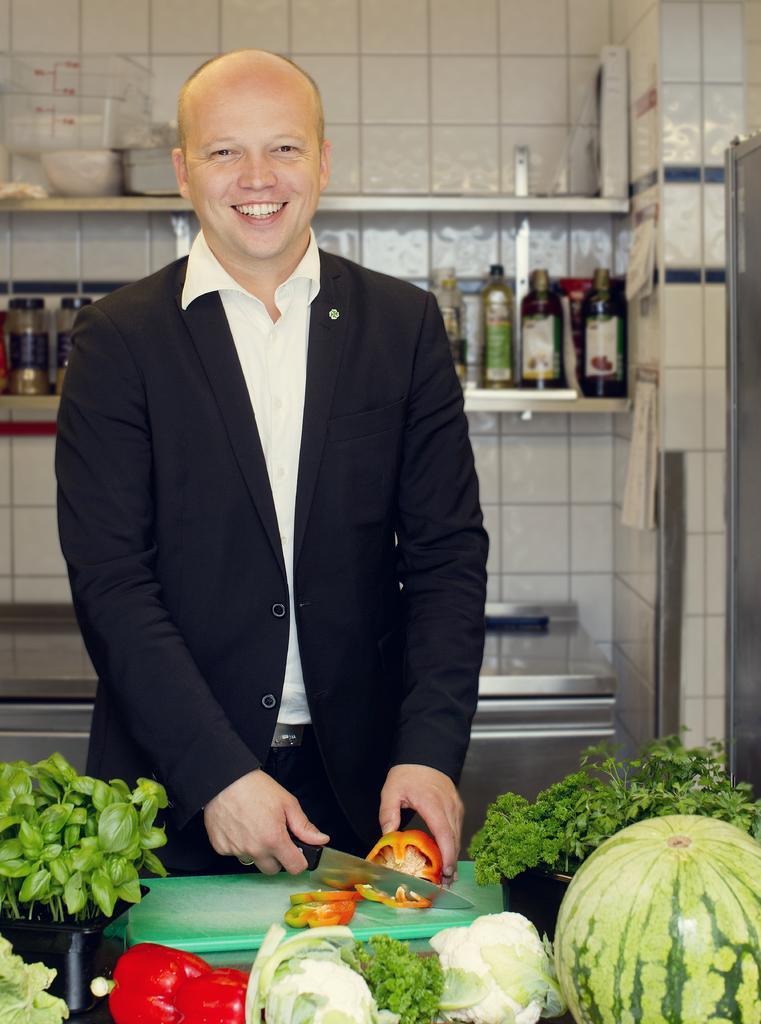Describe this image in one or two sentences. A person is standing wearing suit and holding a knife in his hand. In front of him there is a chopping board, vegetables and watermelon. Behind him there are bottles in the shelves. 